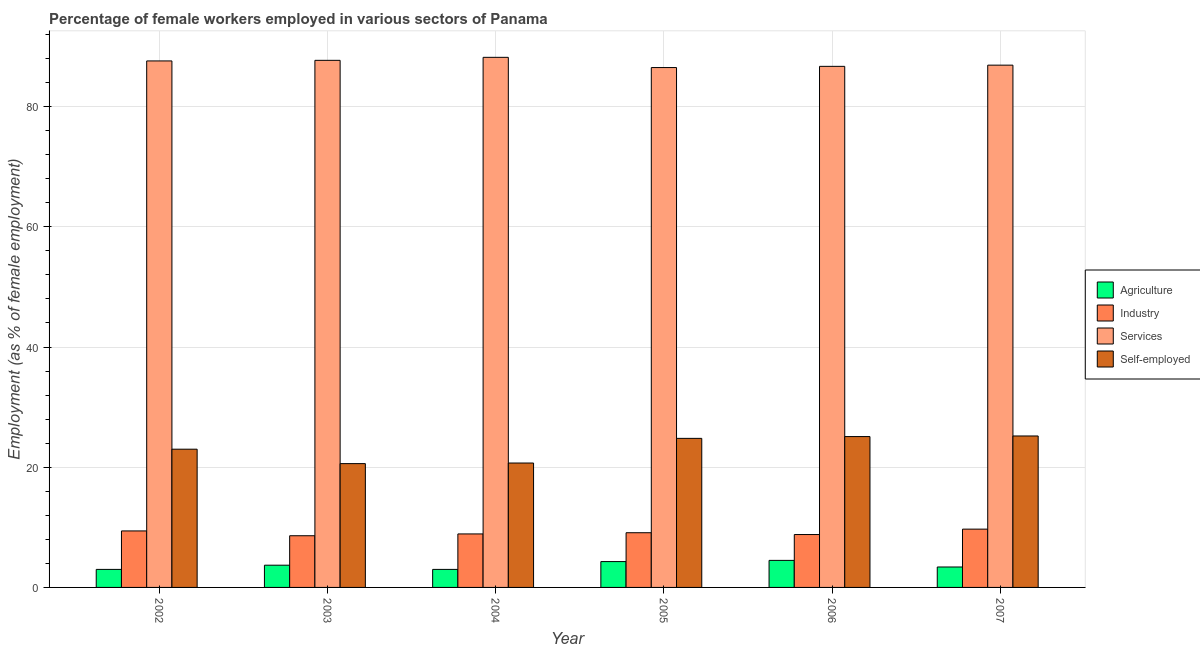How many different coloured bars are there?
Ensure brevity in your answer.  4. Are the number of bars on each tick of the X-axis equal?
Offer a terse response. Yes. How many bars are there on the 5th tick from the left?
Offer a terse response. 4. How many bars are there on the 1st tick from the right?
Ensure brevity in your answer.  4. In how many cases, is the number of bars for a given year not equal to the number of legend labels?
Provide a short and direct response. 0. What is the percentage of self employed female workers in 2006?
Offer a terse response. 25.1. Across all years, what is the maximum percentage of female workers in agriculture?
Offer a very short reply. 4.5. Across all years, what is the minimum percentage of self employed female workers?
Your response must be concise. 20.6. In which year was the percentage of female workers in industry maximum?
Your response must be concise. 2007. What is the total percentage of female workers in industry in the graph?
Keep it short and to the point. 54.5. What is the difference between the percentage of female workers in agriculture in 2005 and the percentage of female workers in industry in 2003?
Make the answer very short. 0.6. What is the average percentage of self employed female workers per year?
Provide a short and direct response. 23.23. In how many years, is the percentage of female workers in industry greater than 8 %?
Your answer should be compact. 6. What is the ratio of the percentage of female workers in services in 2006 to that in 2007?
Make the answer very short. 1. What is the difference between the highest and the second highest percentage of female workers in industry?
Provide a short and direct response. 0.3. In how many years, is the percentage of self employed female workers greater than the average percentage of self employed female workers taken over all years?
Provide a succinct answer. 3. Is the sum of the percentage of female workers in services in 2006 and 2007 greater than the maximum percentage of female workers in industry across all years?
Your response must be concise. Yes. Is it the case that in every year, the sum of the percentage of female workers in agriculture and percentage of female workers in services is greater than the sum of percentage of female workers in industry and percentage of self employed female workers?
Offer a terse response. No. What does the 2nd bar from the left in 2007 represents?
Ensure brevity in your answer.  Industry. What does the 3rd bar from the right in 2004 represents?
Your answer should be compact. Industry. Are all the bars in the graph horizontal?
Offer a very short reply. No. How many years are there in the graph?
Provide a short and direct response. 6. Does the graph contain any zero values?
Give a very brief answer. No. Does the graph contain grids?
Provide a short and direct response. Yes. How many legend labels are there?
Your response must be concise. 4. How are the legend labels stacked?
Your answer should be compact. Vertical. What is the title of the graph?
Offer a terse response. Percentage of female workers employed in various sectors of Panama. Does "Financial sector" appear as one of the legend labels in the graph?
Your response must be concise. No. What is the label or title of the Y-axis?
Offer a very short reply. Employment (as % of female employment). What is the Employment (as % of female employment) in Agriculture in 2002?
Keep it short and to the point. 3. What is the Employment (as % of female employment) of Industry in 2002?
Offer a very short reply. 9.4. What is the Employment (as % of female employment) in Services in 2002?
Give a very brief answer. 87.6. What is the Employment (as % of female employment) of Agriculture in 2003?
Give a very brief answer. 3.7. What is the Employment (as % of female employment) of Industry in 2003?
Give a very brief answer. 8.6. What is the Employment (as % of female employment) in Services in 2003?
Offer a very short reply. 87.7. What is the Employment (as % of female employment) in Self-employed in 2003?
Provide a short and direct response. 20.6. What is the Employment (as % of female employment) in Industry in 2004?
Provide a short and direct response. 8.9. What is the Employment (as % of female employment) of Services in 2004?
Keep it short and to the point. 88.2. What is the Employment (as % of female employment) in Self-employed in 2004?
Offer a very short reply. 20.7. What is the Employment (as % of female employment) of Agriculture in 2005?
Your answer should be compact. 4.3. What is the Employment (as % of female employment) in Industry in 2005?
Your answer should be very brief. 9.1. What is the Employment (as % of female employment) of Services in 2005?
Provide a succinct answer. 86.5. What is the Employment (as % of female employment) in Self-employed in 2005?
Keep it short and to the point. 24.8. What is the Employment (as % of female employment) of Industry in 2006?
Offer a terse response. 8.8. What is the Employment (as % of female employment) of Services in 2006?
Ensure brevity in your answer.  86.7. What is the Employment (as % of female employment) of Self-employed in 2006?
Your response must be concise. 25.1. What is the Employment (as % of female employment) of Agriculture in 2007?
Offer a terse response. 3.4. What is the Employment (as % of female employment) of Industry in 2007?
Keep it short and to the point. 9.7. What is the Employment (as % of female employment) of Services in 2007?
Keep it short and to the point. 86.9. What is the Employment (as % of female employment) of Self-employed in 2007?
Your answer should be compact. 25.2. Across all years, what is the maximum Employment (as % of female employment) of Agriculture?
Keep it short and to the point. 4.5. Across all years, what is the maximum Employment (as % of female employment) in Industry?
Keep it short and to the point. 9.7. Across all years, what is the maximum Employment (as % of female employment) of Services?
Provide a succinct answer. 88.2. Across all years, what is the maximum Employment (as % of female employment) in Self-employed?
Your answer should be compact. 25.2. Across all years, what is the minimum Employment (as % of female employment) of Industry?
Give a very brief answer. 8.6. Across all years, what is the minimum Employment (as % of female employment) in Services?
Provide a short and direct response. 86.5. Across all years, what is the minimum Employment (as % of female employment) of Self-employed?
Your response must be concise. 20.6. What is the total Employment (as % of female employment) in Agriculture in the graph?
Your response must be concise. 21.9. What is the total Employment (as % of female employment) of Industry in the graph?
Your answer should be very brief. 54.5. What is the total Employment (as % of female employment) in Services in the graph?
Provide a succinct answer. 523.6. What is the total Employment (as % of female employment) in Self-employed in the graph?
Keep it short and to the point. 139.4. What is the difference between the Employment (as % of female employment) of Agriculture in 2002 and that in 2003?
Give a very brief answer. -0.7. What is the difference between the Employment (as % of female employment) of Agriculture in 2002 and that in 2004?
Your answer should be compact. 0. What is the difference between the Employment (as % of female employment) in Industry in 2002 and that in 2004?
Provide a short and direct response. 0.5. What is the difference between the Employment (as % of female employment) in Self-employed in 2002 and that in 2005?
Give a very brief answer. -1.8. What is the difference between the Employment (as % of female employment) in Services in 2002 and that in 2006?
Offer a terse response. 0.9. What is the difference between the Employment (as % of female employment) in Self-employed in 2002 and that in 2007?
Keep it short and to the point. -2.2. What is the difference between the Employment (as % of female employment) in Services in 2003 and that in 2004?
Offer a very short reply. -0.5. What is the difference between the Employment (as % of female employment) of Self-employed in 2003 and that in 2004?
Your answer should be very brief. -0.1. What is the difference between the Employment (as % of female employment) in Agriculture in 2003 and that in 2005?
Your answer should be compact. -0.6. What is the difference between the Employment (as % of female employment) in Services in 2003 and that in 2005?
Your answer should be very brief. 1.2. What is the difference between the Employment (as % of female employment) of Self-employed in 2003 and that in 2005?
Provide a succinct answer. -4.2. What is the difference between the Employment (as % of female employment) of Agriculture in 2003 and that in 2006?
Ensure brevity in your answer.  -0.8. What is the difference between the Employment (as % of female employment) of Industry in 2003 and that in 2007?
Offer a terse response. -1.1. What is the difference between the Employment (as % of female employment) of Self-employed in 2003 and that in 2007?
Provide a short and direct response. -4.6. What is the difference between the Employment (as % of female employment) in Agriculture in 2004 and that in 2005?
Offer a terse response. -1.3. What is the difference between the Employment (as % of female employment) of Industry in 2004 and that in 2005?
Make the answer very short. -0.2. What is the difference between the Employment (as % of female employment) of Self-employed in 2004 and that in 2005?
Offer a very short reply. -4.1. What is the difference between the Employment (as % of female employment) of Services in 2004 and that in 2006?
Give a very brief answer. 1.5. What is the difference between the Employment (as % of female employment) of Industry in 2004 and that in 2007?
Keep it short and to the point. -0.8. What is the difference between the Employment (as % of female employment) in Services in 2004 and that in 2007?
Your answer should be very brief. 1.3. What is the difference between the Employment (as % of female employment) of Self-employed in 2004 and that in 2007?
Ensure brevity in your answer.  -4.5. What is the difference between the Employment (as % of female employment) of Agriculture in 2005 and that in 2007?
Make the answer very short. 0.9. What is the difference between the Employment (as % of female employment) of Industry in 2005 and that in 2007?
Offer a very short reply. -0.6. What is the difference between the Employment (as % of female employment) in Services in 2005 and that in 2007?
Give a very brief answer. -0.4. What is the difference between the Employment (as % of female employment) of Industry in 2006 and that in 2007?
Keep it short and to the point. -0.9. What is the difference between the Employment (as % of female employment) in Services in 2006 and that in 2007?
Offer a terse response. -0.2. What is the difference between the Employment (as % of female employment) of Agriculture in 2002 and the Employment (as % of female employment) of Services in 2003?
Make the answer very short. -84.7. What is the difference between the Employment (as % of female employment) in Agriculture in 2002 and the Employment (as % of female employment) in Self-employed in 2003?
Offer a terse response. -17.6. What is the difference between the Employment (as % of female employment) in Industry in 2002 and the Employment (as % of female employment) in Services in 2003?
Provide a short and direct response. -78.3. What is the difference between the Employment (as % of female employment) of Industry in 2002 and the Employment (as % of female employment) of Self-employed in 2003?
Your response must be concise. -11.2. What is the difference between the Employment (as % of female employment) in Services in 2002 and the Employment (as % of female employment) in Self-employed in 2003?
Give a very brief answer. 67. What is the difference between the Employment (as % of female employment) in Agriculture in 2002 and the Employment (as % of female employment) in Industry in 2004?
Your response must be concise. -5.9. What is the difference between the Employment (as % of female employment) of Agriculture in 2002 and the Employment (as % of female employment) of Services in 2004?
Your answer should be very brief. -85.2. What is the difference between the Employment (as % of female employment) of Agriculture in 2002 and the Employment (as % of female employment) of Self-employed in 2004?
Provide a succinct answer. -17.7. What is the difference between the Employment (as % of female employment) in Industry in 2002 and the Employment (as % of female employment) in Services in 2004?
Offer a very short reply. -78.8. What is the difference between the Employment (as % of female employment) of Services in 2002 and the Employment (as % of female employment) of Self-employed in 2004?
Your response must be concise. 66.9. What is the difference between the Employment (as % of female employment) of Agriculture in 2002 and the Employment (as % of female employment) of Services in 2005?
Make the answer very short. -83.5. What is the difference between the Employment (as % of female employment) of Agriculture in 2002 and the Employment (as % of female employment) of Self-employed in 2005?
Make the answer very short. -21.8. What is the difference between the Employment (as % of female employment) in Industry in 2002 and the Employment (as % of female employment) in Services in 2005?
Ensure brevity in your answer.  -77.1. What is the difference between the Employment (as % of female employment) in Industry in 2002 and the Employment (as % of female employment) in Self-employed in 2005?
Offer a terse response. -15.4. What is the difference between the Employment (as % of female employment) in Services in 2002 and the Employment (as % of female employment) in Self-employed in 2005?
Your response must be concise. 62.8. What is the difference between the Employment (as % of female employment) of Agriculture in 2002 and the Employment (as % of female employment) of Services in 2006?
Your answer should be compact. -83.7. What is the difference between the Employment (as % of female employment) in Agriculture in 2002 and the Employment (as % of female employment) in Self-employed in 2006?
Make the answer very short. -22.1. What is the difference between the Employment (as % of female employment) of Industry in 2002 and the Employment (as % of female employment) of Services in 2006?
Your answer should be compact. -77.3. What is the difference between the Employment (as % of female employment) in Industry in 2002 and the Employment (as % of female employment) in Self-employed in 2006?
Give a very brief answer. -15.7. What is the difference between the Employment (as % of female employment) in Services in 2002 and the Employment (as % of female employment) in Self-employed in 2006?
Offer a very short reply. 62.5. What is the difference between the Employment (as % of female employment) of Agriculture in 2002 and the Employment (as % of female employment) of Services in 2007?
Keep it short and to the point. -83.9. What is the difference between the Employment (as % of female employment) of Agriculture in 2002 and the Employment (as % of female employment) of Self-employed in 2007?
Your answer should be compact. -22.2. What is the difference between the Employment (as % of female employment) in Industry in 2002 and the Employment (as % of female employment) in Services in 2007?
Make the answer very short. -77.5. What is the difference between the Employment (as % of female employment) of Industry in 2002 and the Employment (as % of female employment) of Self-employed in 2007?
Provide a short and direct response. -15.8. What is the difference between the Employment (as % of female employment) in Services in 2002 and the Employment (as % of female employment) in Self-employed in 2007?
Your answer should be very brief. 62.4. What is the difference between the Employment (as % of female employment) of Agriculture in 2003 and the Employment (as % of female employment) of Industry in 2004?
Ensure brevity in your answer.  -5.2. What is the difference between the Employment (as % of female employment) of Agriculture in 2003 and the Employment (as % of female employment) of Services in 2004?
Offer a very short reply. -84.5. What is the difference between the Employment (as % of female employment) of Agriculture in 2003 and the Employment (as % of female employment) of Self-employed in 2004?
Ensure brevity in your answer.  -17. What is the difference between the Employment (as % of female employment) in Industry in 2003 and the Employment (as % of female employment) in Services in 2004?
Keep it short and to the point. -79.6. What is the difference between the Employment (as % of female employment) in Industry in 2003 and the Employment (as % of female employment) in Self-employed in 2004?
Keep it short and to the point. -12.1. What is the difference between the Employment (as % of female employment) of Agriculture in 2003 and the Employment (as % of female employment) of Industry in 2005?
Your response must be concise. -5.4. What is the difference between the Employment (as % of female employment) in Agriculture in 2003 and the Employment (as % of female employment) in Services in 2005?
Your answer should be very brief. -82.8. What is the difference between the Employment (as % of female employment) in Agriculture in 2003 and the Employment (as % of female employment) in Self-employed in 2005?
Keep it short and to the point. -21.1. What is the difference between the Employment (as % of female employment) in Industry in 2003 and the Employment (as % of female employment) in Services in 2005?
Offer a terse response. -77.9. What is the difference between the Employment (as % of female employment) in Industry in 2003 and the Employment (as % of female employment) in Self-employed in 2005?
Make the answer very short. -16.2. What is the difference between the Employment (as % of female employment) of Services in 2003 and the Employment (as % of female employment) of Self-employed in 2005?
Ensure brevity in your answer.  62.9. What is the difference between the Employment (as % of female employment) in Agriculture in 2003 and the Employment (as % of female employment) in Industry in 2006?
Make the answer very short. -5.1. What is the difference between the Employment (as % of female employment) of Agriculture in 2003 and the Employment (as % of female employment) of Services in 2006?
Your response must be concise. -83. What is the difference between the Employment (as % of female employment) in Agriculture in 2003 and the Employment (as % of female employment) in Self-employed in 2006?
Your response must be concise. -21.4. What is the difference between the Employment (as % of female employment) in Industry in 2003 and the Employment (as % of female employment) in Services in 2006?
Ensure brevity in your answer.  -78.1. What is the difference between the Employment (as % of female employment) of Industry in 2003 and the Employment (as % of female employment) of Self-employed in 2006?
Offer a very short reply. -16.5. What is the difference between the Employment (as % of female employment) of Services in 2003 and the Employment (as % of female employment) of Self-employed in 2006?
Offer a very short reply. 62.6. What is the difference between the Employment (as % of female employment) of Agriculture in 2003 and the Employment (as % of female employment) of Industry in 2007?
Keep it short and to the point. -6. What is the difference between the Employment (as % of female employment) in Agriculture in 2003 and the Employment (as % of female employment) in Services in 2007?
Offer a terse response. -83.2. What is the difference between the Employment (as % of female employment) in Agriculture in 2003 and the Employment (as % of female employment) in Self-employed in 2007?
Provide a short and direct response. -21.5. What is the difference between the Employment (as % of female employment) of Industry in 2003 and the Employment (as % of female employment) of Services in 2007?
Your answer should be compact. -78.3. What is the difference between the Employment (as % of female employment) of Industry in 2003 and the Employment (as % of female employment) of Self-employed in 2007?
Ensure brevity in your answer.  -16.6. What is the difference between the Employment (as % of female employment) in Services in 2003 and the Employment (as % of female employment) in Self-employed in 2007?
Make the answer very short. 62.5. What is the difference between the Employment (as % of female employment) of Agriculture in 2004 and the Employment (as % of female employment) of Industry in 2005?
Your answer should be compact. -6.1. What is the difference between the Employment (as % of female employment) of Agriculture in 2004 and the Employment (as % of female employment) of Services in 2005?
Ensure brevity in your answer.  -83.5. What is the difference between the Employment (as % of female employment) in Agriculture in 2004 and the Employment (as % of female employment) in Self-employed in 2005?
Provide a succinct answer. -21.8. What is the difference between the Employment (as % of female employment) of Industry in 2004 and the Employment (as % of female employment) of Services in 2005?
Provide a succinct answer. -77.6. What is the difference between the Employment (as % of female employment) in Industry in 2004 and the Employment (as % of female employment) in Self-employed in 2005?
Make the answer very short. -15.9. What is the difference between the Employment (as % of female employment) in Services in 2004 and the Employment (as % of female employment) in Self-employed in 2005?
Your response must be concise. 63.4. What is the difference between the Employment (as % of female employment) of Agriculture in 2004 and the Employment (as % of female employment) of Services in 2006?
Your answer should be compact. -83.7. What is the difference between the Employment (as % of female employment) of Agriculture in 2004 and the Employment (as % of female employment) of Self-employed in 2006?
Ensure brevity in your answer.  -22.1. What is the difference between the Employment (as % of female employment) of Industry in 2004 and the Employment (as % of female employment) of Services in 2006?
Your response must be concise. -77.8. What is the difference between the Employment (as % of female employment) in Industry in 2004 and the Employment (as % of female employment) in Self-employed in 2006?
Provide a succinct answer. -16.2. What is the difference between the Employment (as % of female employment) in Services in 2004 and the Employment (as % of female employment) in Self-employed in 2006?
Make the answer very short. 63.1. What is the difference between the Employment (as % of female employment) of Agriculture in 2004 and the Employment (as % of female employment) of Industry in 2007?
Your answer should be compact. -6.7. What is the difference between the Employment (as % of female employment) in Agriculture in 2004 and the Employment (as % of female employment) in Services in 2007?
Offer a very short reply. -83.9. What is the difference between the Employment (as % of female employment) of Agriculture in 2004 and the Employment (as % of female employment) of Self-employed in 2007?
Make the answer very short. -22.2. What is the difference between the Employment (as % of female employment) of Industry in 2004 and the Employment (as % of female employment) of Services in 2007?
Provide a succinct answer. -78. What is the difference between the Employment (as % of female employment) of Industry in 2004 and the Employment (as % of female employment) of Self-employed in 2007?
Your answer should be compact. -16.3. What is the difference between the Employment (as % of female employment) of Services in 2004 and the Employment (as % of female employment) of Self-employed in 2007?
Offer a very short reply. 63. What is the difference between the Employment (as % of female employment) in Agriculture in 2005 and the Employment (as % of female employment) in Industry in 2006?
Give a very brief answer. -4.5. What is the difference between the Employment (as % of female employment) of Agriculture in 2005 and the Employment (as % of female employment) of Services in 2006?
Provide a succinct answer. -82.4. What is the difference between the Employment (as % of female employment) of Agriculture in 2005 and the Employment (as % of female employment) of Self-employed in 2006?
Your answer should be very brief. -20.8. What is the difference between the Employment (as % of female employment) in Industry in 2005 and the Employment (as % of female employment) in Services in 2006?
Provide a short and direct response. -77.6. What is the difference between the Employment (as % of female employment) in Industry in 2005 and the Employment (as % of female employment) in Self-employed in 2006?
Ensure brevity in your answer.  -16. What is the difference between the Employment (as % of female employment) of Services in 2005 and the Employment (as % of female employment) of Self-employed in 2006?
Offer a very short reply. 61.4. What is the difference between the Employment (as % of female employment) in Agriculture in 2005 and the Employment (as % of female employment) in Services in 2007?
Give a very brief answer. -82.6. What is the difference between the Employment (as % of female employment) of Agriculture in 2005 and the Employment (as % of female employment) of Self-employed in 2007?
Your answer should be very brief. -20.9. What is the difference between the Employment (as % of female employment) of Industry in 2005 and the Employment (as % of female employment) of Services in 2007?
Keep it short and to the point. -77.8. What is the difference between the Employment (as % of female employment) in Industry in 2005 and the Employment (as % of female employment) in Self-employed in 2007?
Offer a very short reply. -16.1. What is the difference between the Employment (as % of female employment) in Services in 2005 and the Employment (as % of female employment) in Self-employed in 2007?
Give a very brief answer. 61.3. What is the difference between the Employment (as % of female employment) of Agriculture in 2006 and the Employment (as % of female employment) of Industry in 2007?
Make the answer very short. -5.2. What is the difference between the Employment (as % of female employment) in Agriculture in 2006 and the Employment (as % of female employment) in Services in 2007?
Offer a terse response. -82.4. What is the difference between the Employment (as % of female employment) of Agriculture in 2006 and the Employment (as % of female employment) of Self-employed in 2007?
Your answer should be very brief. -20.7. What is the difference between the Employment (as % of female employment) of Industry in 2006 and the Employment (as % of female employment) of Services in 2007?
Keep it short and to the point. -78.1. What is the difference between the Employment (as % of female employment) in Industry in 2006 and the Employment (as % of female employment) in Self-employed in 2007?
Give a very brief answer. -16.4. What is the difference between the Employment (as % of female employment) of Services in 2006 and the Employment (as % of female employment) of Self-employed in 2007?
Keep it short and to the point. 61.5. What is the average Employment (as % of female employment) in Agriculture per year?
Provide a succinct answer. 3.65. What is the average Employment (as % of female employment) of Industry per year?
Offer a terse response. 9.08. What is the average Employment (as % of female employment) in Services per year?
Offer a very short reply. 87.27. What is the average Employment (as % of female employment) in Self-employed per year?
Provide a succinct answer. 23.23. In the year 2002, what is the difference between the Employment (as % of female employment) in Agriculture and Employment (as % of female employment) in Services?
Give a very brief answer. -84.6. In the year 2002, what is the difference between the Employment (as % of female employment) in Agriculture and Employment (as % of female employment) in Self-employed?
Your response must be concise. -20. In the year 2002, what is the difference between the Employment (as % of female employment) of Industry and Employment (as % of female employment) of Services?
Give a very brief answer. -78.2. In the year 2002, what is the difference between the Employment (as % of female employment) in Services and Employment (as % of female employment) in Self-employed?
Provide a succinct answer. 64.6. In the year 2003, what is the difference between the Employment (as % of female employment) in Agriculture and Employment (as % of female employment) in Services?
Provide a short and direct response. -84. In the year 2003, what is the difference between the Employment (as % of female employment) in Agriculture and Employment (as % of female employment) in Self-employed?
Your response must be concise. -16.9. In the year 2003, what is the difference between the Employment (as % of female employment) of Industry and Employment (as % of female employment) of Services?
Make the answer very short. -79.1. In the year 2003, what is the difference between the Employment (as % of female employment) in Industry and Employment (as % of female employment) in Self-employed?
Your answer should be compact. -12. In the year 2003, what is the difference between the Employment (as % of female employment) in Services and Employment (as % of female employment) in Self-employed?
Provide a short and direct response. 67.1. In the year 2004, what is the difference between the Employment (as % of female employment) of Agriculture and Employment (as % of female employment) of Services?
Make the answer very short. -85.2. In the year 2004, what is the difference between the Employment (as % of female employment) of Agriculture and Employment (as % of female employment) of Self-employed?
Provide a succinct answer. -17.7. In the year 2004, what is the difference between the Employment (as % of female employment) in Industry and Employment (as % of female employment) in Services?
Offer a terse response. -79.3. In the year 2004, what is the difference between the Employment (as % of female employment) in Industry and Employment (as % of female employment) in Self-employed?
Ensure brevity in your answer.  -11.8. In the year 2004, what is the difference between the Employment (as % of female employment) of Services and Employment (as % of female employment) of Self-employed?
Make the answer very short. 67.5. In the year 2005, what is the difference between the Employment (as % of female employment) in Agriculture and Employment (as % of female employment) in Industry?
Provide a short and direct response. -4.8. In the year 2005, what is the difference between the Employment (as % of female employment) in Agriculture and Employment (as % of female employment) in Services?
Provide a succinct answer. -82.2. In the year 2005, what is the difference between the Employment (as % of female employment) in Agriculture and Employment (as % of female employment) in Self-employed?
Make the answer very short. -20.5. In the year 2005, what is the difference between the Employment (as % of female employment) of Industry and Employment (as % of female employment) of Services?
Provide a succinct answer. -77.4. In the year 2005, what is the difference between the Employment (as % of female employment) in Industry and Employment (as % of female employment) in Self-employed?
Ensure brevity in your answer.  -15.7. In the year 2005, what is the difference between the Employment (as % of female employment) of Services and Employment (as % of female employment) of Self-employed?
Provide a short and direct response. 61.7. In the year 2006, what is the difference between the Employment (as % of female employment) of Agriculture and Employment (as % of female employment) of Services?
Your answer should be compact. -82.2. In the year 2006, what is the difference between the Employment (as % of female employment) in Agriculture and Employment (as % of female employment) in Self-employed?
Ensure brevity in your answer.  -20.6. In the year 2006, what is the difference between the Employment (as % of female employment) in Industry and Employment (as % of female employment) in Services?
Your answer should be very brief. -77.9. In the year 2006, what is the difference between the Employment (as % of female employment) in Industry and Employment (as % of female employment) in Self-employed?
Offer a very short reply. -16.3. In the year 2006, what is the difference between the Employment (as % of female employment) of Services and Employment (as % of female employment) of Self-employed?
Provide a succinct answer. 61.6. In the year 2007, what is the difference between the Employment (as % of female employment) of Agriculture and Employment (as % of female employment) of Industry?
Your response must be concise. -6.3. In the year 2007, what is the difference between the Employment (as % of female employment) in Agriculture and Employment (as % of female employment) in Services?
Offer a very short reply. -83.5. In the year 2007, what is the difference between the Employment (as % of female employment) in Agriculture and Employment (as % of female employment) in Self-employed?
Offer a very short reply. -21.8. In the year 2007, what is the difference between the Employment (as % of female employment) in Industry and Employment (as % of female employment) in Services?
Give a very brief answer. -77.2. In the year 2007, what is the difference between the Employment (as % of female employment) of Industry and Employment (as % of female employment) of Self-employed?
Offer a very short reply. -15.5. In the year 2007, what is the difference between the Employment (as % of female employment) of Services and Employment (as % of female employment) of Self-employed?
Your response must be concise. 61.7. What is the ratio of the Employment (as % of female employment) in Agriculture in 2002 to that in 2003?
Give a very brief answer. 0.81. What is the ratio of the Employment (as % of female employment) in Industry in 2002 to that in 2003?
Offer a very short reply. 1.09. What is the ratio of the Employment (as % of female employment) of Services in 2002 to that in 2003?
Offer a very short reply. 1. What is the ratio of the Employment (as % of female employment) of Self-employed in 2002 to that in 2003?
Offer a terse response. 1.12. What is the ratio of the Employment (as % of female employment) in Industry in 2002 to that in 2004?
Provide a short and direct response. 1.06. What is the ratio of the Employment (as % of female employment) in Services in 2002 to that in 2004?
Keep it short and to the point. 0.99. What is the ratio of the Employment (as % of female employment) in Self-employed in 2002 to that in 2004?
Your answer should be compact. 1.11. What is the ratio of the Employment (as % of female employment) of Agriculture in 2002 to that in 2005?
Ensure brevity in your answer.  0.7. What is the ratio of the Employment (as % of female employment) in Industry in 2002 to that in 2005?
Offer a terse response. 1.03. What is the ratio of the Employment (as % of female employment) of Services in 2002 to that in 2005?
Provide a short and direct response. 1.01. What is the ratio of the Employment (as % of female employment) of Self-employed in 2002 to that in 2005?
Your answer should be compact. 0.93. What is the ratio of the Employment (as % of female employment) in Agriculture in 2002 to that in 2006?
Your response must be concise. 0.67. What is the ratio of the Employment (as % of female employment) of Industry in 2002 to that in 2006?
Ensure brevity in your answer.  1.07. What is the ratio of the Employment (as % of female employment) in Services in 2002 to that in 2006?
Make the answer very short. 1.01. What is the ratio of the Employment (as % of female employment) of Self-employed in 2002 to that in 2006?
Provide a succinct answer. 0.92. What is the ratio of the Employment (as % of female employment) in Agriculture in 2002 to that in 2007?
Give a very brief answer. 0.88. What is the ratio of the Employment (as % of female employment) of Industry in 2002 to that in 2007?
Offer a terse response. 0.97. What is the ratio of the Employment (as % of female employment) in Self-employed in 2002 to that in 2007?
Ensure brevity in your answer.  0.91. What is the ratio of the Employment (as % of female employment) of Agriculture in 2003 to that in 2004?
Provide a succinct answer. 1.23. What is the ratio of the Employment (as % of female employment) of Industry in 2003 to that in 2004?
Your answer should be compact. 0.97. What is the ratio of the Employment (as % of female employment) in Services in 2003 to that in 2004?
Your answer should be very brief. 0.99. What is the ratio of the Employment (as % of female employment) of Self-employed in 2003 to that in 2004?
Provide a short and direct response. 1. What is the ratio of the Employment (as % of female employment) in Agriculture in 2003 to that in 2005?
Your answer should be very brief. 0.86. What is the ratio of the Employment (as % of female employment) in Industry in 2003 to that in 2005?
Keep it short and to the point. 0.95. What is the ratio of the Employment (as % of female employment) of Services in 2003 to that in 2005?
Your answer should be compact. 1.01. What is the ratio of the Employment (as % of female employment) in Self-employed in 2003 to that in 2005?
Your response must be concise. 0.83. What is the ratio of the Employment (as % of female employment) of Agriculture in 2003 to that in 2006?
Your response must be concise. 0.82. What is the ratio of the Employment (as % of female employment) in Industry in 2003 to that in 2006?
Your answer should be very brief. 0.98. What is the ratio of the Employment (as % of female employment) of Services in 2003 to that in 2006?
Make the answer very short. 1.01. What is the ratio of the Employment (as % of female employment) of Self-employed in 2003 to that in 2006?
Your response must be concise. 0.82. What is the ratio of the Employment (as % of female employment) of Agriculture in 2003 to that in 2007?
Ensure brevity in your answer.  1.09. What is the ratio of the Employment (as % of female employment) of Industry in 2003 to that in 2007?
Offer a terse response. 0.89. What is the ratio of the Employment (as % of female employment) in Services in 2003 to that in 2007?
Give a very brief answer. 1.01. What is the ratio of the Employment (as % of female employment) in Self-employed in 2003 to that in 2007?
Offer a very short reply. 0.82. What is the ratio of the Employment (as % of female employment) of Agriculture in 2004 to that in 2005?
Provide a short and direct response. 0.7. What is the ratio of the Employment (as % of female employment) of Industry in 2004 to that in 2005?
Your answer should be compact. 0.98. What is the ratio of the Employment (as % of female employment) in Services in 2004 to that in 2005?
Make the answer very short. 1.02. What is the ratio of the Employment (as % of female employment) of Self-employed in 2004 to that in 2005?
Keep it short and to the point. 0.83. What is the ratio of the Employment (as % of female employment) in Agriculture in 2004 to that in 2006?
Give a very brief answer. 0.67. What is the ratio of the Employment (as % of female employment) of Industry in 2004 to that in 2006?
Offer a terse response. 1.01. What is the ratio of the Employment (as % of female employment) of Services in 2004 to that in 2006?
Make the answer very short. 1.02. What is the ratio of the Employment (as % of female employment) of Self-employed in 2004 to that in 2006?
Offer a very short reply. 0.82. What is the ratio of the Employment (as % of female employment) in Agriculture in 2004 to that in 2007?
Your response must be concise. 0.88. What is the ratio of the Employment (as % of female employment) in Industry in 2004 to that in 2007?
Offer a terse response. 0.92. What is the ratio of the Employment (as % of female employment) of Self-employed in 2004 to that in 2007?
Make the answer very short. 0.82. What is the ratio of the Employment (as % of female employment) in Agriculture in 2005 to that in 2006?
Give a very brief answer. 0.96. What is the ratio of the Employment (as % of female employment) in Industry in 2005 to that in 2006?
Provide a succinct answer. 1.03. What is the ratio of the Employment (as % of female employment) of Self-employed in 2005 to that in 2006?
Offer a very short reply. 0.99. What is the ratio of the Employment (as % of female employment) of Agriculture in 2005 to that in 2007?
Give a very brief answer. 1.26. What is the ratio of the Employment (as % of female employment) in Industry in 2005 to that in 2007?
Your response must be concise. 0.94. What is the ratio of the Employment (as % of female employment) in Self-employed in 2005 to that in 2007?
Your response must be concise. 0.98. What is the ratio of the Employment (as % of female employment) of Agriculture in 2006 to that in 2007?
Your answer should be very brief. 1.32. What is the ratio of the Employment (as % of female employment) of Industry in 2006 to that in 2007?
Your answer should be very brief. 0.91. What is the difference between the highest and the second highest Employment (as % of female employment) in Services?
Offer a terse response. 0.5. What is the difference between the highest and the second highest Employment (as % of female employment) of Self-employed?
Ensure brevity in your answer.  0.1. What is the difference between the highest and the lowest Employment (as % of female employment) in Industry?
Give a very brief answer. 1.1. What is the difference between the highest and the lowest Employment (as % of female employment) in Self-employed?
Give a very brief answer. 4.6. 